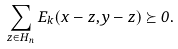<formula> <loc_0><loc_0><loc_500><loc_500>\sum _ { z \in H _ { n } } E _ { k } ( x - z , y - z ) \succeq 0 .</formula> 